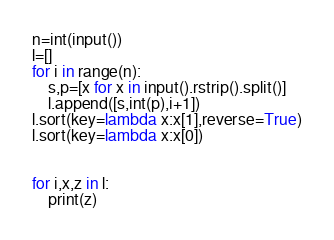<code> <loc_0><loc_0><loc_500><loc_500><_Python_>n=int(input())
l=[]
for i in range(n):
    s,p=[x for x in input().rstrip().split()]
    l.append([s,int(p),i+1])
l.sort(key=lambda x:x[1],reverse=True)
l.sort(key=lambda x:x[0])


for i,x,z in l:
    print(z)


</code> 